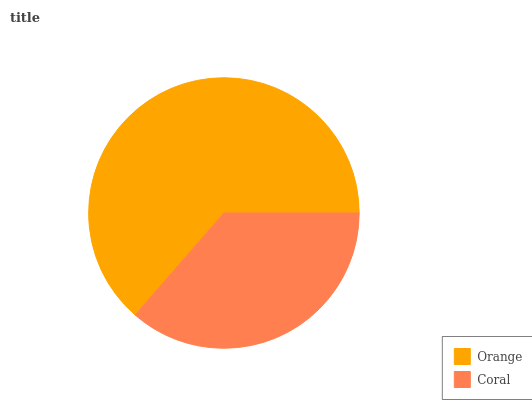Is Coral the minimum?
Answer yes or no. Yes. Is Orange the maximum?
Answer yes or no. Yes. Is Coral the maximum?
Answer yes or no. No. Is Orange greater than Coral?
Answer yes or no. Yes. Is Coral less than Orange?
Answer yes or no. Yes. Is Coral greater than Orange?
Answer yes or no. No. Is Orange less than Coral?
Answer yes or no. No. Is Orange the high median?
Answer yes or no. Yes. Is Coral the low median?
Answer yes or no. Yes. Is Coral the high median?
Answer yes or no. No. Is Orange the low median?
Answer yes or no. No. 